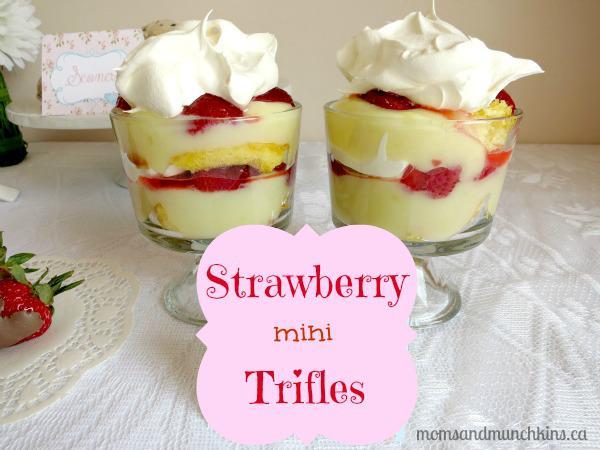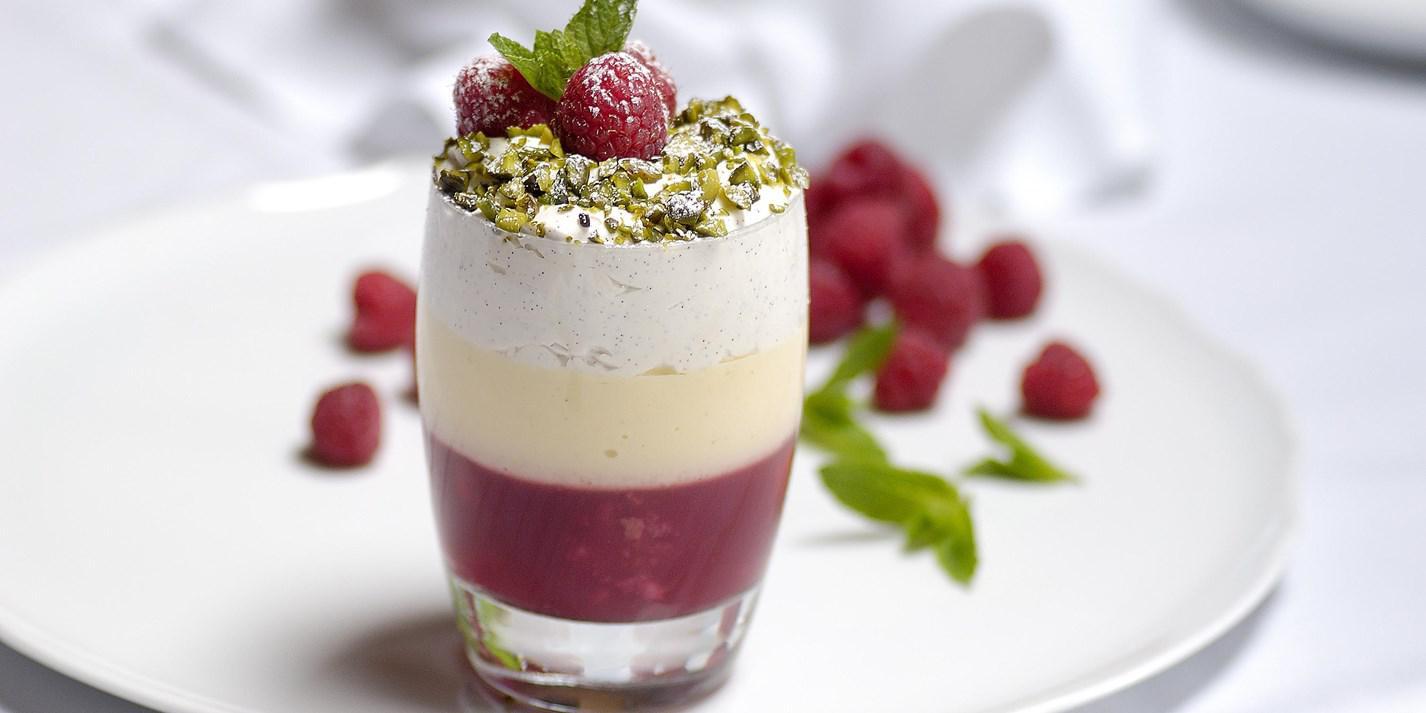The first image is the image on the left, the second image is the image on the right. Evaluate the accuracy of this statement regarding the images: "The left photo contains two cups full of dessert.". Is it true? Answer yes or no. Yes. The first image is the image on the left, the second image is the image on the right. Evaluate the accuracy of this statement regarding the images: "One of the images shows exactly one dessert container.". Is it true? Answer yes or no. Yes. 